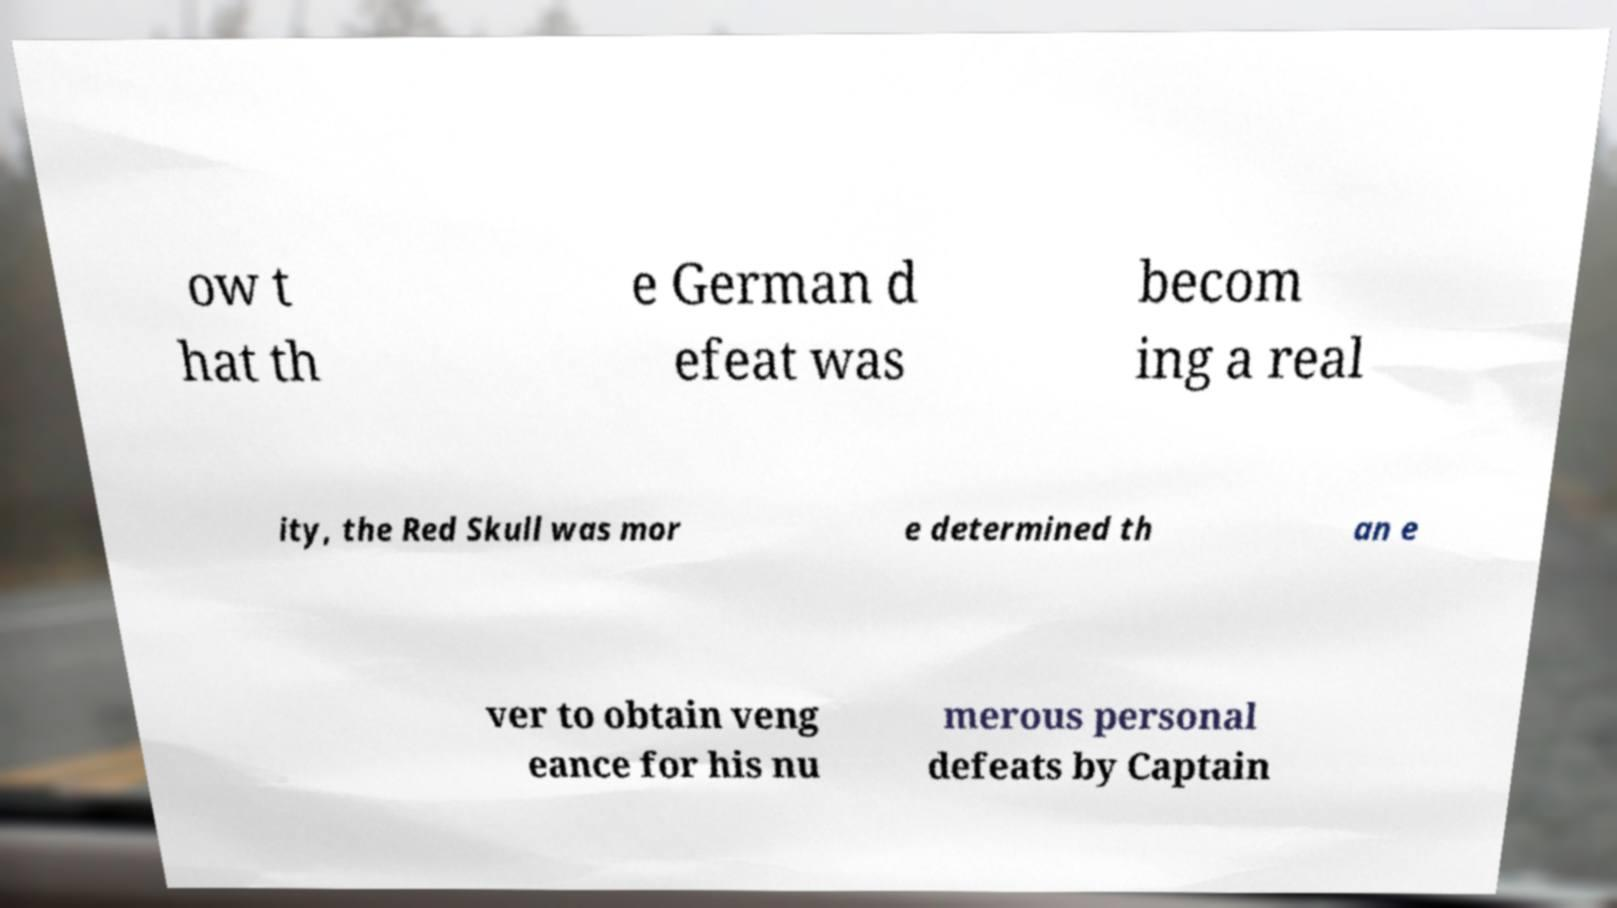Could you assist in decoding the text presented in this image and type it out clearly? ow t hat th e German d efeat was becom ing a real ity, the Red Skull was mor e determined th an e ver to obtain veng eance for his nu merous personal defeats by Captain 